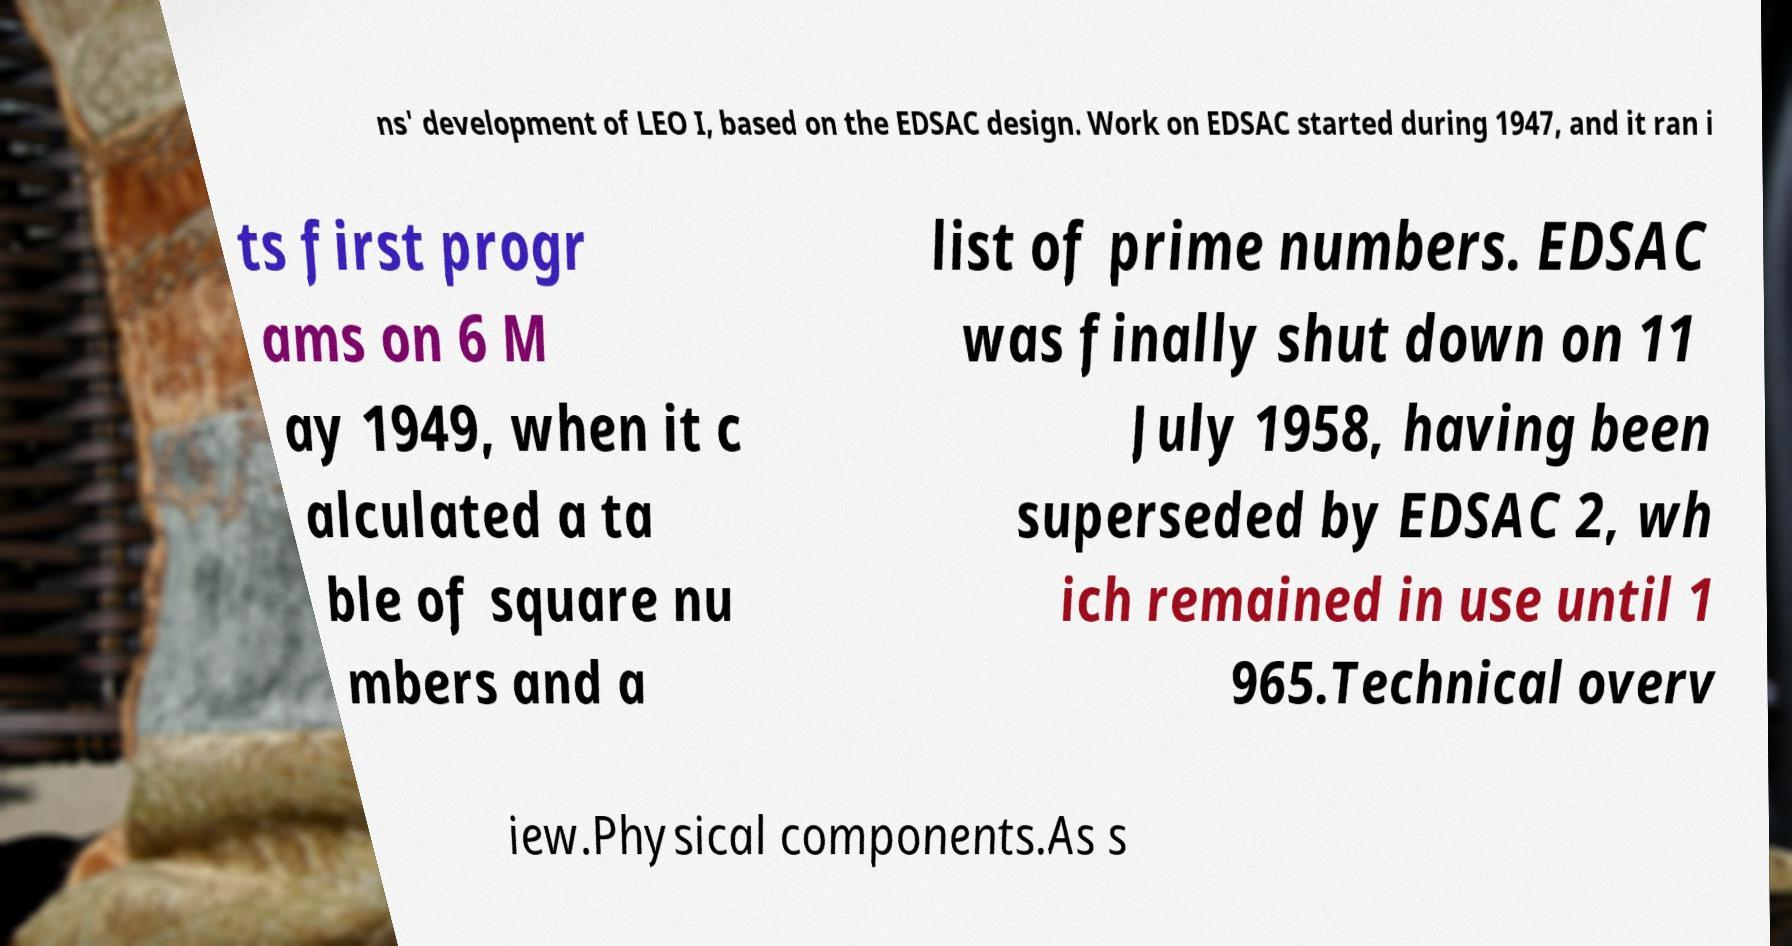What messages or text are displayed in this image? I need them in a readable, typed format. ns' development of LEO I, based on the EDSAC design. Work on EDSAC started during 1947, and it ran i ts first progr ams on 6 M ay 1949, when it c alculated a ta ble of square nu mbers and a list of prime numbers. EDSAC was finally shut down on 11 July 1958, having been superseded by EDSAC 2, wh ich remained in use until 1 965.Technical overv iew.Physical components.As s 